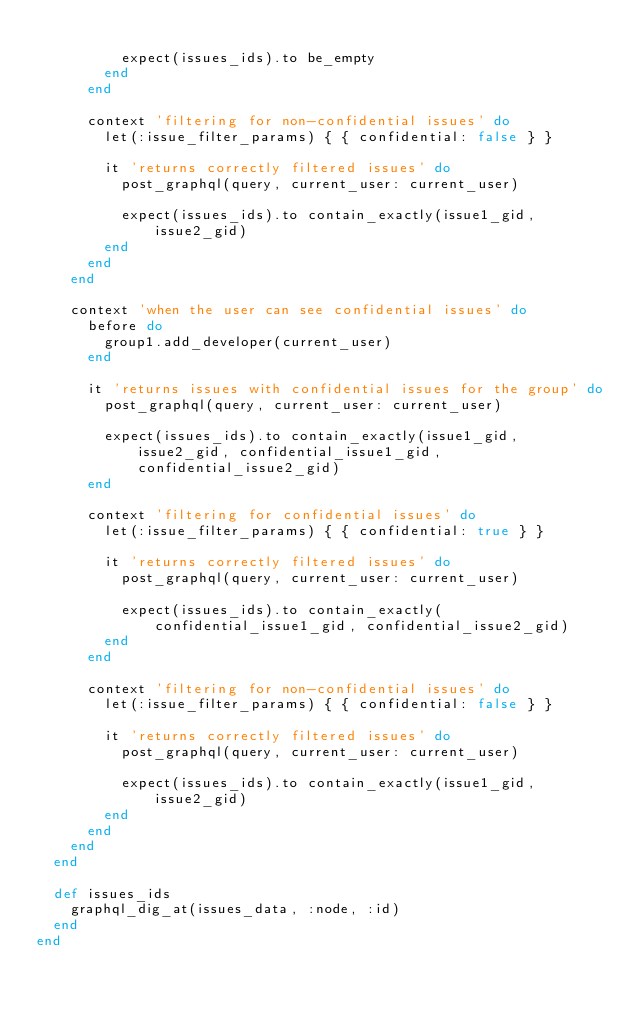<code> <loc_0><loc_0><loc_500><loc_500><_Ruby_>
          expect(issues_ids).to be_empty
        end
      end

      context 'filtering for non-confidential issues' do
        let(:issue_filter_params) { { confidential: false } }

        it 'returns correctly filtered issues' do
          post_graphql(query, current_user: current_user)

          expect(issues_ids).to contain_exactly(issue1_gid, issue2_gid)
        end
      end
    end

    context 'when the user can see confidential issues' do
      before do
        group1.add_developer(current_user)
      end

      it 'returns issues with confidential issues for the group' do
        post_graphql(query, current_user: current_user)

        expect(issues_ids).to contain_exactly(issue1_gid, issue2_gid, confidential_issue1_gid, confidential_issue2_gid)
      end

      context 'filtering for confidential issues' do
        let(:issue_filter_params) { { confidential: true } }

        it 'returns correctly filtered issues' do
          post_graphql(query, current_user: current_user)

          expect(issues_ids).to contain_exactly(confidential_issue1_gid, confidential_issue2_gid)
        end
      end

      context 'filtering for non-confidential issues' do
        let(:issue_filter_params) { { confidential: false } }

        it 'returns correctly filtered issues' do
          post_graphql(query, current_user: current_user)

          expect(issues_ids).to contain_exactly(issue1_gid, issue2_gid)
        end
      end
    end
  end

  def issues_ids
    graphql_dig_at(issues_data, :node, :id)
  end
end
</code> 